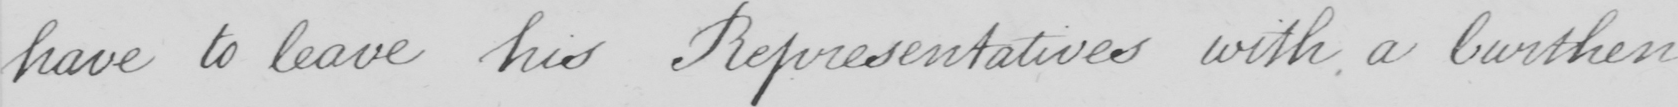Can you read and transcribe this handwriting? have to leave his Representatives with a burthen 